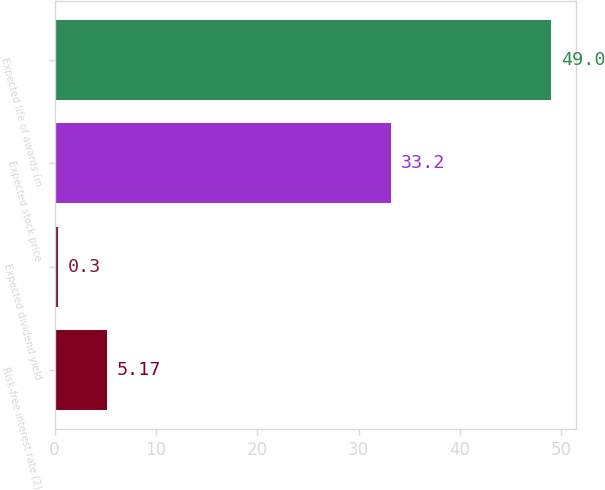Convert chart. <chart><loc_0><loc_0><loc_500><loc_500><bar_chart><fcel>Risk-free interest rate (2)<fcel>Expected dividend yield<fcel>Expected stock price<fcel>Expected life of awards (in<nl><fcel>5.17<fcel>0.3<fcel>33.2<fcel>49<nl></chart> 